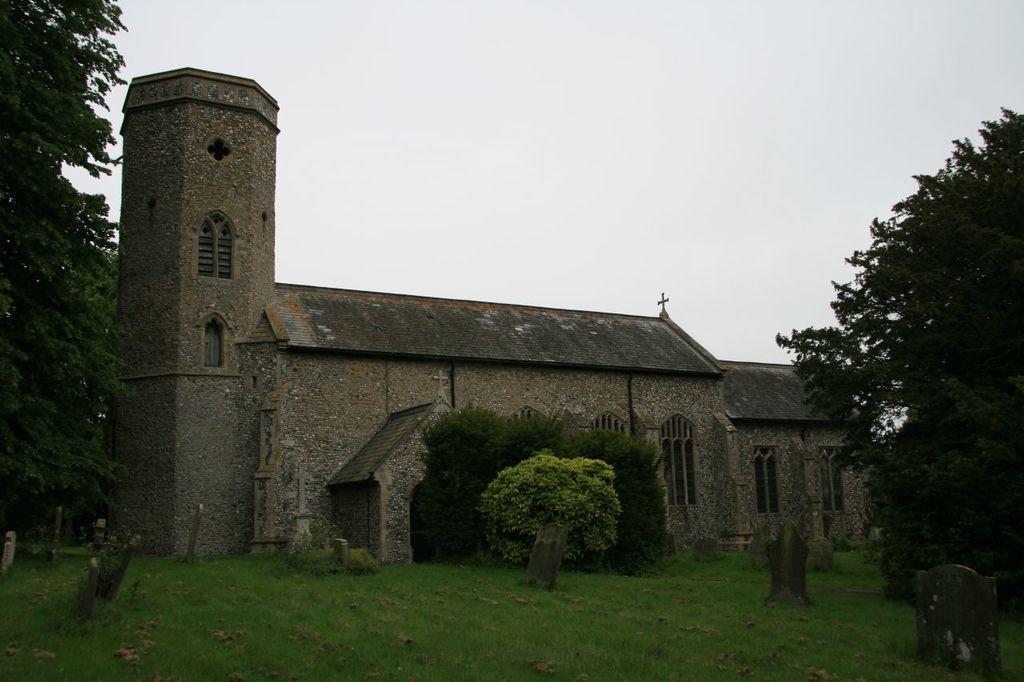How would you summarize this image in a sentence or two? In this image we can see the church, trees, grass and also the graveyard stones. We can also see the sky at the top. 